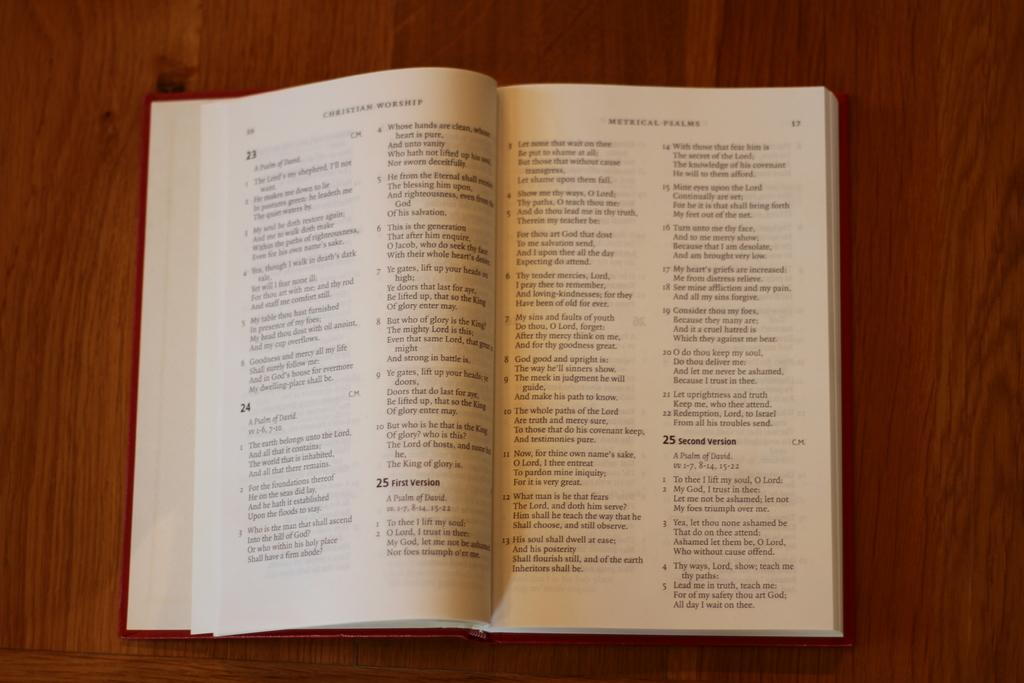Provide a one-sentence caption for the provided image. Christian Worship book with different verses and psalms. 